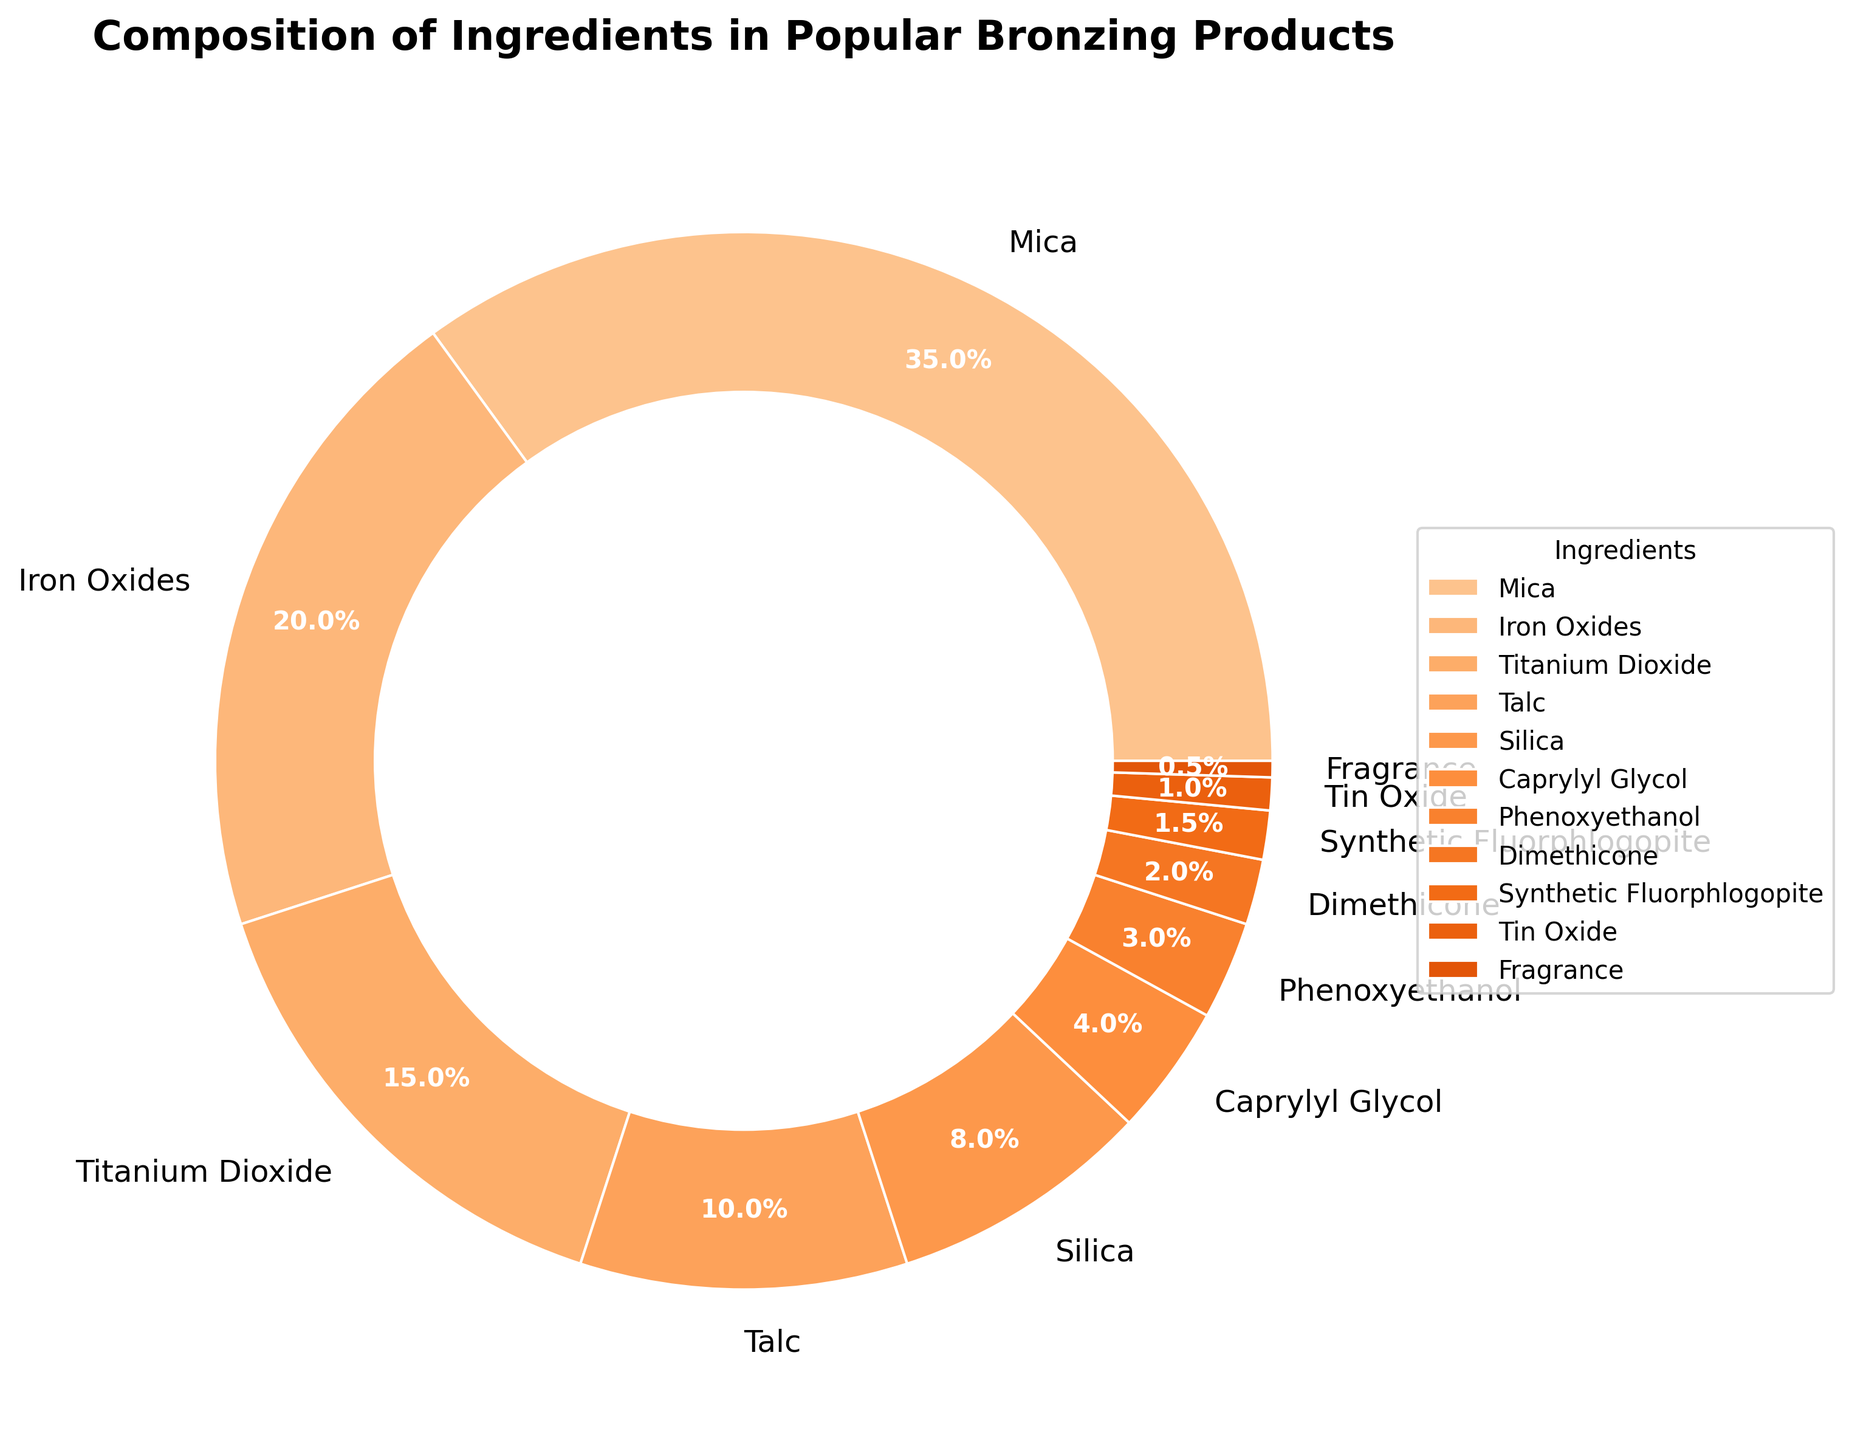What is the most common ingredient used in popular bronzing products? By looking at the pie chart, the largest section corresponds to the product Mica, which occupies the greatest percentage.
Answer: Mica How many ingredients make up at least 5% each of the composition of popular bronzing products? When scanning the pie chart, the products with 5% or more are Mica (35%), Iron Oxides (20%), Titanium Dioxide (15%), Talc (10%), and Silica (8%). Counting these, we get 1 + 1 + 1 + 1 + 1 = 5.
Answer: 5 Which ingredient represents the smallest percentage in popular bronzing products? Observing the pie chart, the smallest section belongs to Fragrance, which accounts for only 0.5%.
Answer: Fragrance How does the percentage of Mica compare to the percentage of Talc and Silica combined? Mica is 35%. Talc is 10% and Silica is 8%, hence combined they make up 10% + 8% = 18%. Comparatively, 35% (Mica) is greater than 18% (Talc + Silica).
Answer: Greater What is the total percentage of all ingredients other than Mica, Iron Oxides, and Titanium Dioxide? Mica, Iron Oxides, and Titanium Dioxide are 35%, 20%, and 15%, respectively. Adding these gives 35% + 20% + 15% = 70%. Subtracting from 100%, we get 100% - 70% = 30%.
Answer: 30% What is the difference in percentage between the highest and lowest ingredients? The highest percentage is Mica at 35%, and the lowest is Fragrance at 0.5%. The difference is 35% - 0.5% = 34.5%.
Answer: 34.5% How do the percentages of Caprylyl Glycol and Phenoxyethanol compare to Dimethicone? Caprylyl Glycol is 4%, Phenoxyethanol is 3%, combined they make 4% + 3% = 7%, which is greater than Dimethicone at 2%.
Answer: Greater What percentage of the ingredients are accounted for by products that make up less than 5% each? The ingredients are Caprylyl Glycol (4%), Phenoxyethanol (3%), Dimethicone (2%), Synthetic Fluorphlogopite (1.5%), Tin Oxide (1%), and Fragrance (0.5%). Adding these, we get 4% + 3% + 2% + 1.5% + 1% + 0.5% = 12%.
Answer: 12% 